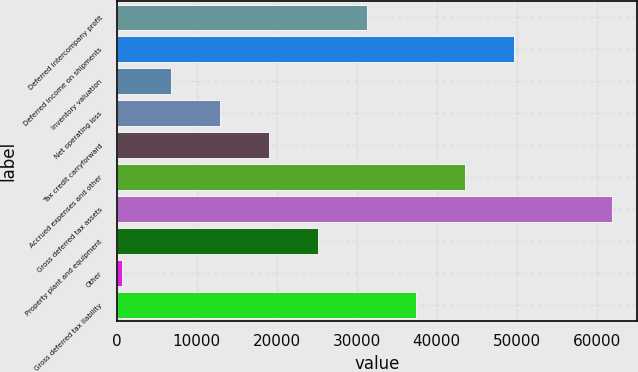<chart> <loc_0><loc_0><loc_500><loc_500><bar_chart><fcel>Deferred intercompany profit<fcel>Deferred income on shipments<fcel>Inventory valuation<fcel>Net operating loss<fcel>Tax credit carryforward<fcel>Accrued expenses and other<fcel>Gross deferred tax assets<fcel>Property plant and equipment<fcel>Other<fcel>Gross deferred tax liability<nl><fcel>31347.5<fcel>49728.8<fcel>6839.1<fcel>12966.2<fcel>19093.3<fcel>43601.7<fcel>61983<fcel>25220.4<fcel>712<fcel>37474.6<nl></chart> 